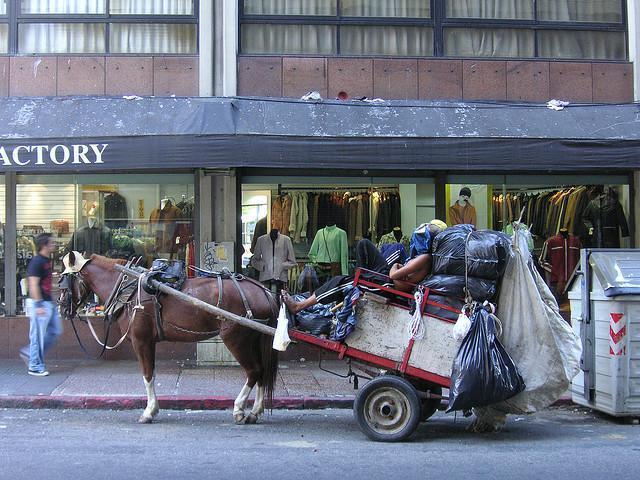How many wheels are on the cart?
Give a very brief answer. 2. How many people are in the photo?
Give a very brief answer. 2. 